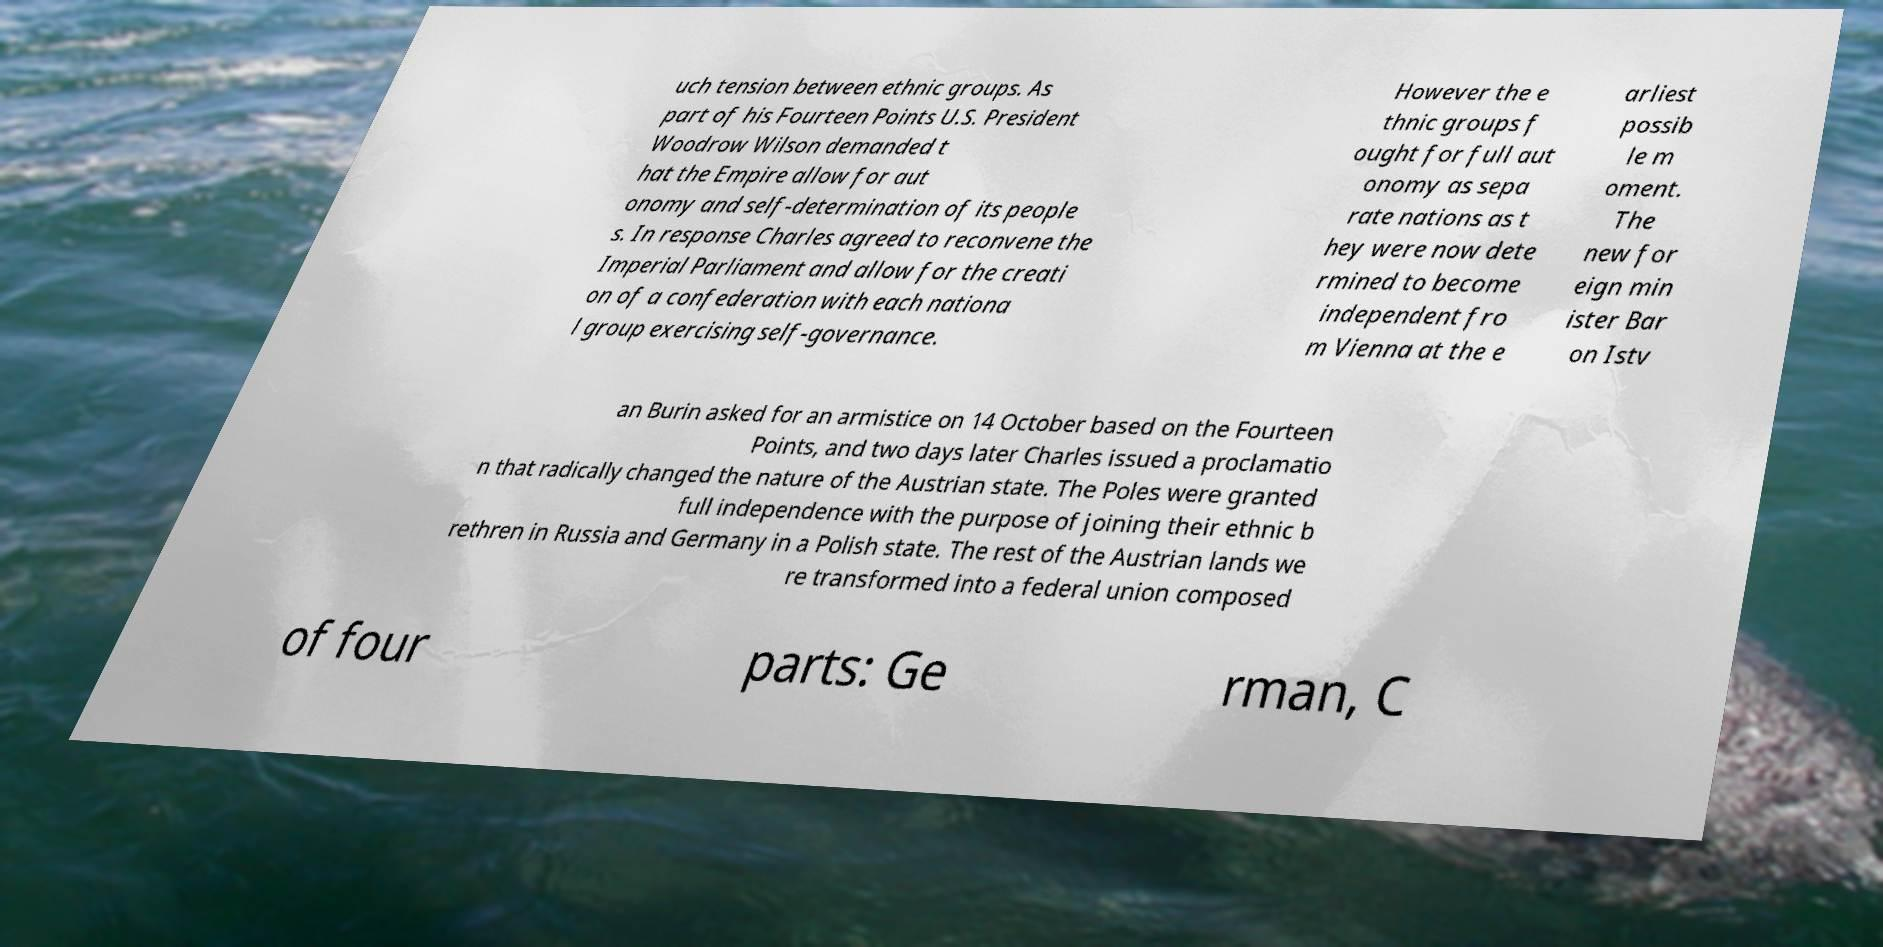I need the written content from this picture converted into text. Can you do that? uch tension between ethnic groups. As part of his Fourteen Points U.S. President Woodrow Wilson demanded t hat the Empire allow for aut onomy and self-determination of its people s. In response Charles agreed to reconvene the Imperial Parliament and allow for the creati on of a confederation with each nationa l group exercising self-governance. However the e thnic groups f ought for full aut onomy as sepa rate nations as t hey were now dete rmined to become independent fro m Vienna at the e arliest possib le m oment. The new for eign min ister Bar on Istv an Burin asked for an armistice on 14 October based on the Fourteen Points, and two days later Charles issued a proclamatio n that radically changed the nature of the Austrian state. The Poles were granted full independence with the purpose of joining their ethnic b rethren in Russia and Germany in a Polish state. The rest of the Austrian lands we re transformed into a federal union composed of four parts: Ge rman, C 